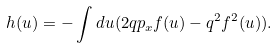Convert formula to latex. <formula><loc_0><loc_0><loc_500><loc_500>h ( u ) = - \int d u ( 2 q p _ { x } f ( u ) - q ^ { 2 } f ^ { 2 } ( u ) ) .</formula> 